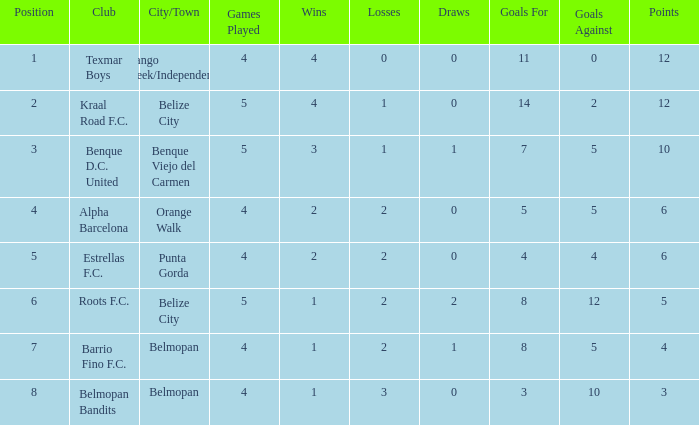What's the goals for/against with w-l-d being 3-1-1 7-5. Parse the table in full. {'header': ['Position', 'Club', 'City/Town', 'Games Played', 'Wins', 'Losses', 'Draws', 'Goals For', 'Goals Against', 'Points'], 'rows': [['1', 'Texmar Boys', 'Mango Creek/Independence', '4', '4', '0', '0', '11', '0', '12'], ['2', 'Kraal Road F.C.', 'Belize City', '5', '4', '1', '0', '14', '2', '12'], ['3', 'Benque D.C. United', 'Benque Viejo del Carmen', '5', '3', '1', '1', '7', '5', '10'], ['4', 'Alpha Barcelona', 'Orange Walk', '4', '2', '2', '0', '5', '5', '6'], ['5', 'Estrellas F.C.', 'Punta Gorda', '4', '2', '2', '0', '4', '4', '6'], ['6', 'Roots F.C.', 'Belize City', '5', '1', '2', '2', '8', '12', '5'], ['7', 'Barrio Fino F.C.', 'Belmopan', '4', '1', '2', '1', '8', '5', '4'], ['8', 'Belmopan Bandits', 'Belmopan', '4', '1', '3', '0', '3', '10', '3']]} 